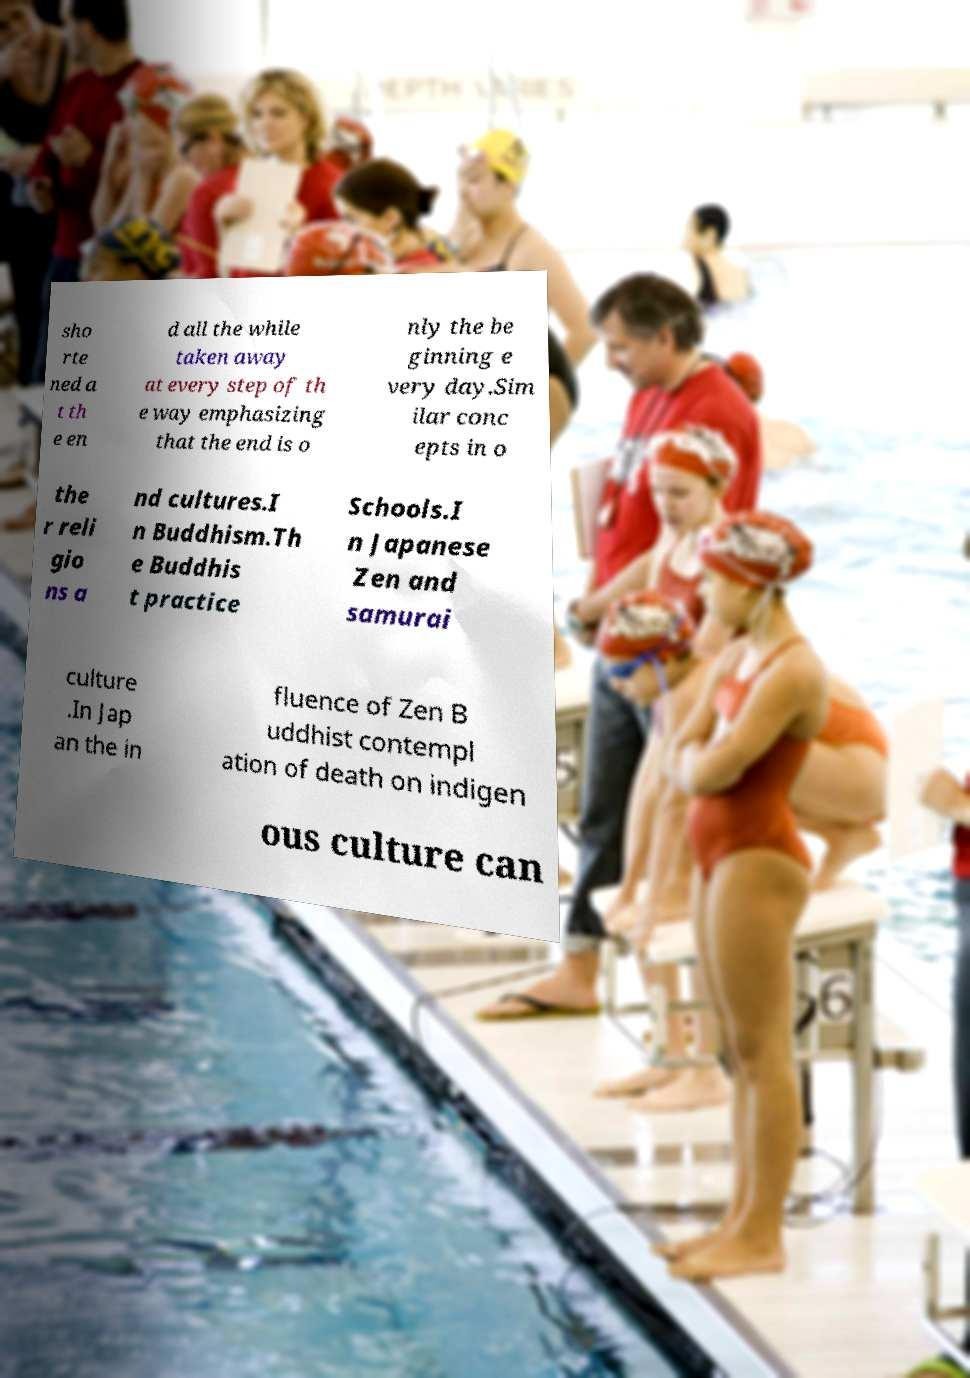Could you assist in decoding the text presented in this image and type it out clearly? sho rte ned a t th e en d all the while taken away at every step of th e way emphasizing that the end is o nly the be ginning e very day.Sim ilar conc epts in o the r reli gio ns a nd cultures.I n Buddhism.Th e Buddhis t practice Schools.I n Japanese Zen and samurai culture .In Jap an the in fluence of Zen B uddhist contempl ation of death on indigen ous culture can 